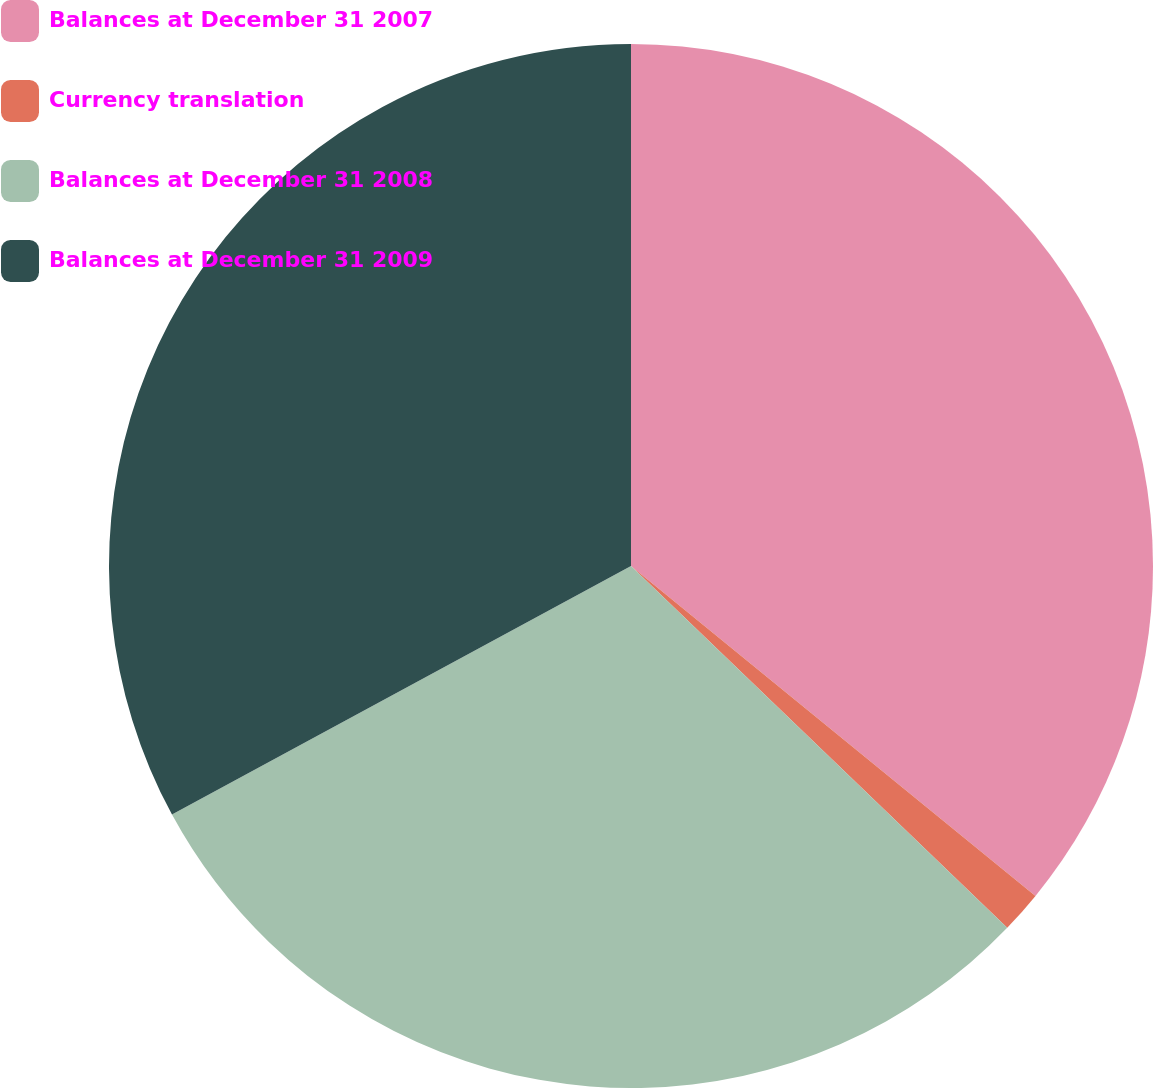Convert chart to OTSL. <chart><loc_0><loc_0><loc_500><loc_500><pie_chart><fcel>Balances at December 31 2007<fcel>Currency translation<fcel>Balances at December 31 2008<fcel>Balances at December 31 2009<nl><fcel>35.89%<fcel>1.3%<fcel>29.91%<fcel>32.9%<nl></chart> 